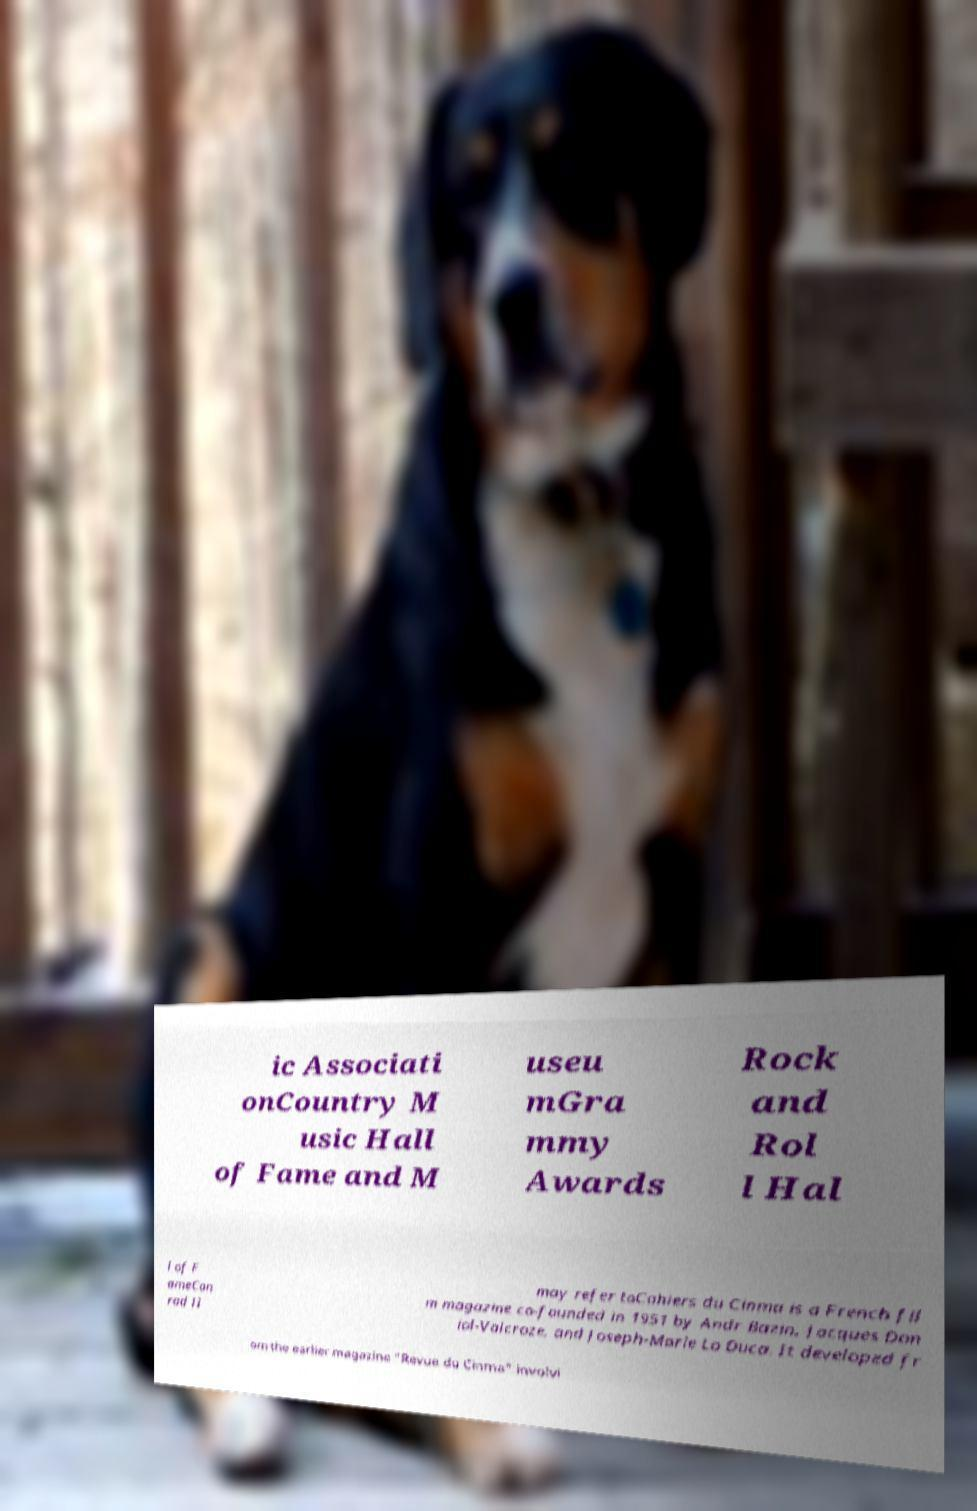Please read and relay the text visible in this image. What does it say? ic Associati onCountry M usic Hall of Fame and M useu mGra mmy Awards Rock and Rol l Hal l of F ameCon rad II may refer toCahiers du Cinma is a French fil m magazine co-founded in 1951 by Andr Bazin, Jacques Don iol-Valcroze, and Joseph-Marie Lo Duca. It developed fr om the earlier magazine "Revue du Cinma" involvi 